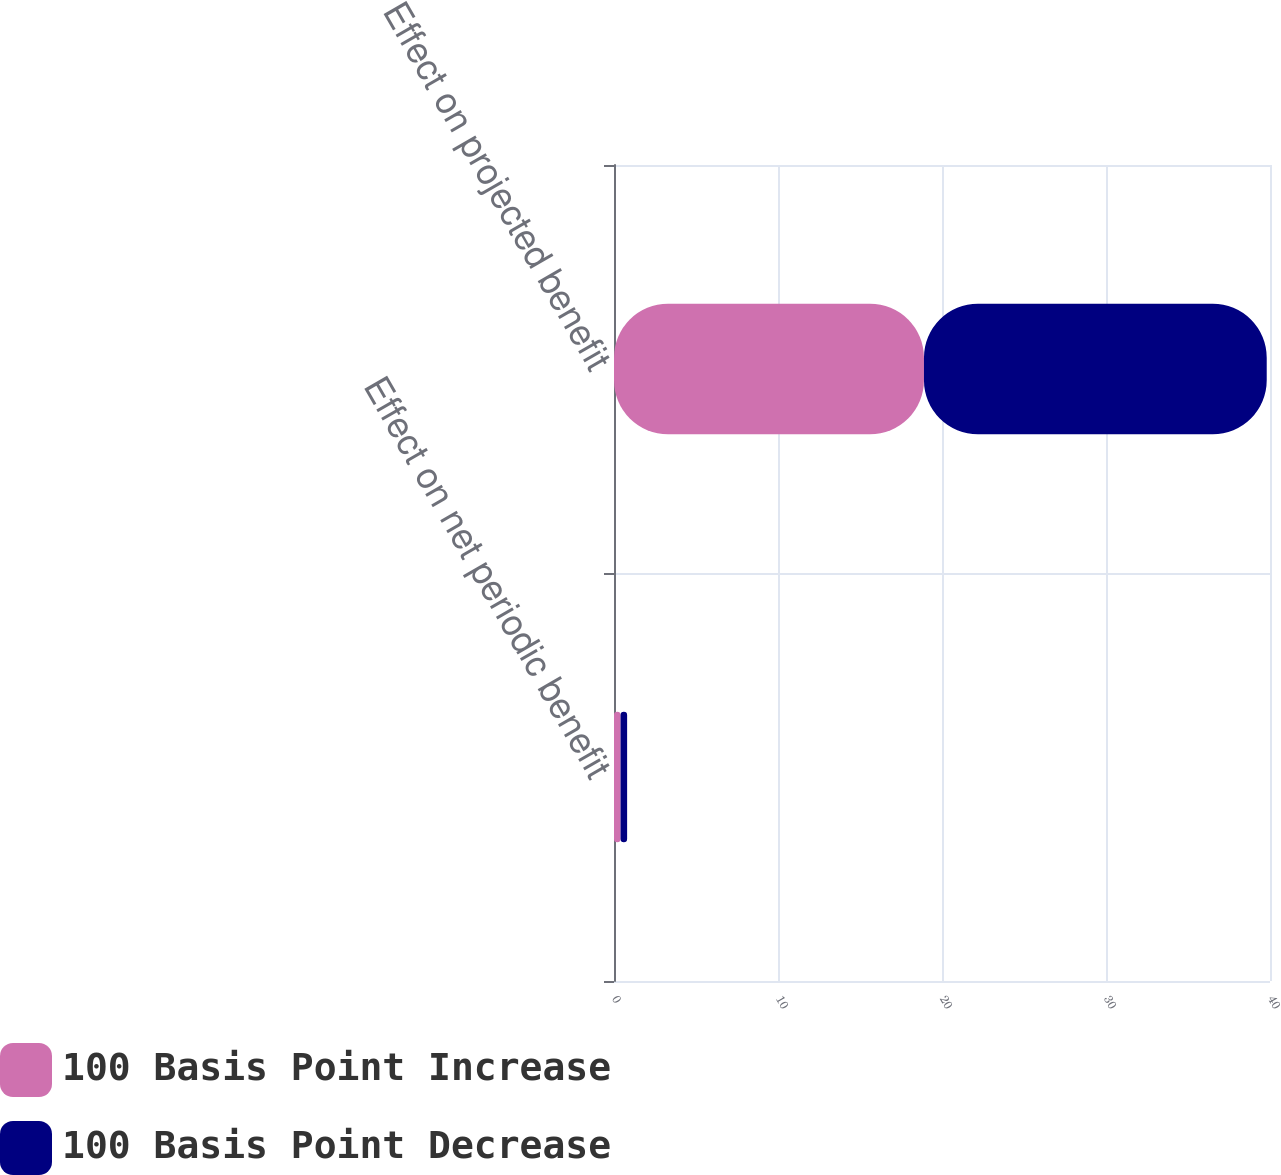Convert chart to OTSL. <chart><loc_0><loc_0><loc_500><loc_500><stacked_bar_chart><ecel><fcel>Effect on net periodic benefit<fcel>Effect on projected benefit<nl><fcel>100 Basis Point Increase<fcel>0.4<fcel>18.9<nl><fcel>100 Basis Point Decrease<fcel>0.4<fcel>20.9<nl></chart> 